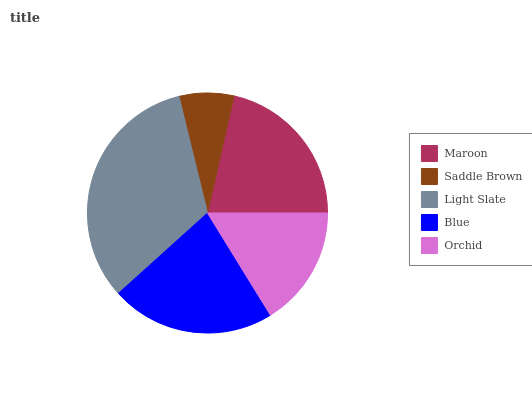Is Saddle Brown the minimum?
Answer yes or no. Yes. Is Light Slate the maximum?
Answer yes or no. Yes. Is Light Slate the minimum?
Answer yes or no. No. Is Saddle Brown the maximum?
Answer yes or no. No. Is Light Slate greater than Saddle Brown?
Answer yes or no. Yes. Is Saddle Brown less than Light Slate?
Answer yes or no. Yes. Is Saddle Brown greater than Light Slate?
Answer yes or no. No. Is Light Slate less than Saddle Brown?
Answer yes or no. No. Is Maroon the high median?
Answer yes or no. Yes. Is Maroon the low median?
Answer yes or no. Yes. Is Light Slate the high median?
Answer yes or no. No. Is Saddle Brown the low median?
Answer yes or no. No. 